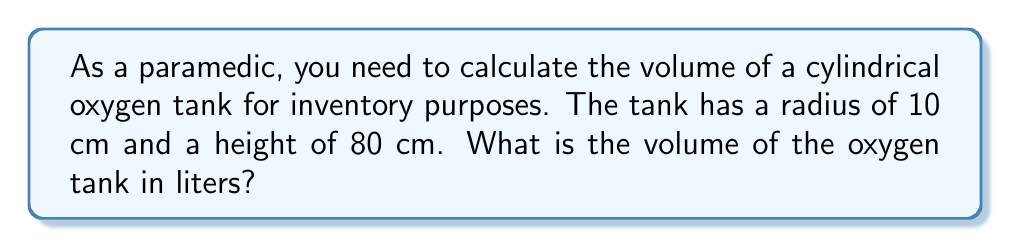Show me your answer to this math problem. To calculate the volume of a cylindrical oxygen tank, we'll use the formula for the volume of a cylinder:

$$V = \pi r^2 h$$

Where:
$V$ = volume
$r$ = radius of the base
$h$ = height of the cylinder

Given:
$r = 10$ cm
$h = 80$ cm

Let's substitute these values into the formula:

$$V = \pi (10 \text{ cm})^2 (80 \text{ cm})$$

$$V = \pi (100 \text{ cm}^2) (80 \text{ cm})$$

$$V = 8000\pi \text{ cm}^3$$

Now, let's calculate this:

$$V \approx 25132.74 \text{ cm}^3$$

To convert cubic centimeters to liters, we divide by 1000:

$$V \text{ (in liters)} = \frac{25132.74 \text{ cm}^3}{1000 \text{ cm}^3/L} \approx 25.13 \text{ L}$$

Therefore, the volume of the oxygen tank is approximately 25.13 liters.
Answer: 25.13 L 